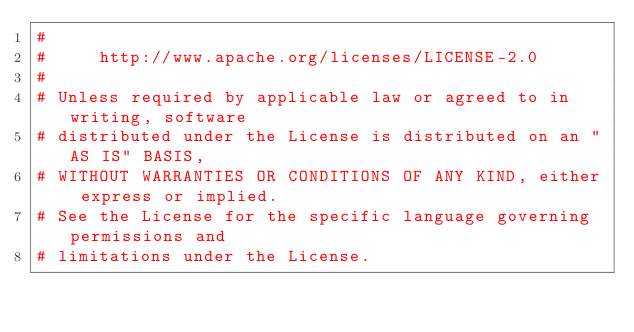Convert code to text. <code><loc_0><loc_0><loc_500><loc_500><_Python_>#
#     http://www.apache.org/licenses/LICENSE-2.0
#
# Unless required by applicable law or agreed to in writing, software
# distributed under the License is distributed on an "AS IS" BASIS,
# WITHOUT WARRANTIES OR CONDITIONS OF ANY KIND, either express or implied.
# See the License for the specific language governing permissions and
# limitations under the License.
</code> 